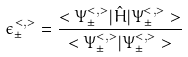Convert formula to latex. <formula><loc_0><loc_0><loc_500><loc_500>\epsilon _ { \pm } ^ { < , > } = \frac { < \Psi _ { \pm } ^ { < , > } | \hat { H } | \Psi _ { \pm } ^ { < , > } > } { < \Psi _ { \pm } ^ { < , > } | \Psi _ { \pm } ^ { < , > } > }</formula> 